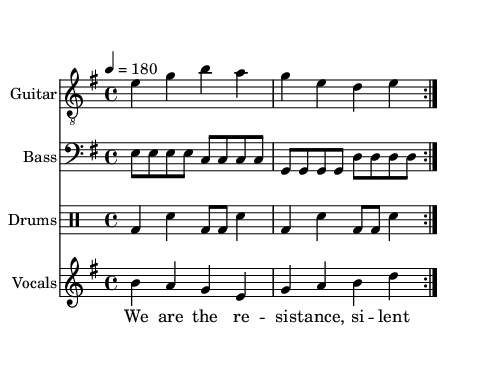What is the key signature of this music? The key signature is indicated at the beginning of the score with the sharp or flat symbols. In this score, it shows E minor which has a single sharp (F#).
Answer: E minor What is the time signature of this music? The time signature is seen next to the key signature at the beginning. This score has a time signature of 4/4, which means there are four beats in each measure.
Answer: 4/4 What is the tempo marking of this piece? The tempo marking is found at the beginning of the score, stating the beats per minute. This score indicates a tempo of 180 beats per minute.
Answer: 180 How many measures is the verse repeated? The verse section code shows a repeat symbol that indicates it is played multiple times. The verse is repeated two times, as indicated by the "repeat volta 2."
Answer: 2 What is the theme of the lyrics in this song? The lyrics reflect themes of resistance and secrecy. The verses speak of hiding and keeping secrets while the chorus emphasizes being a silent but strong underground movement.
Answer: Resistance What is the role of the drums in this punk song? The drums provide a strong, driving beat, which is typical in punk music. The pattern consists of bass drum (bd) and snare (sn) alternating to create an energetic rhythm.
Answer: Energetic rhythm What musical elements indicate this is a punk song? Punk songs often have fast tempos, simple chord structures, and a rebellious spirit in the lyrics. This song matches these characteristics with its fast tempo, minor key, and themes of resistance.
Answer: Fast tempo, rebellious lyrics 